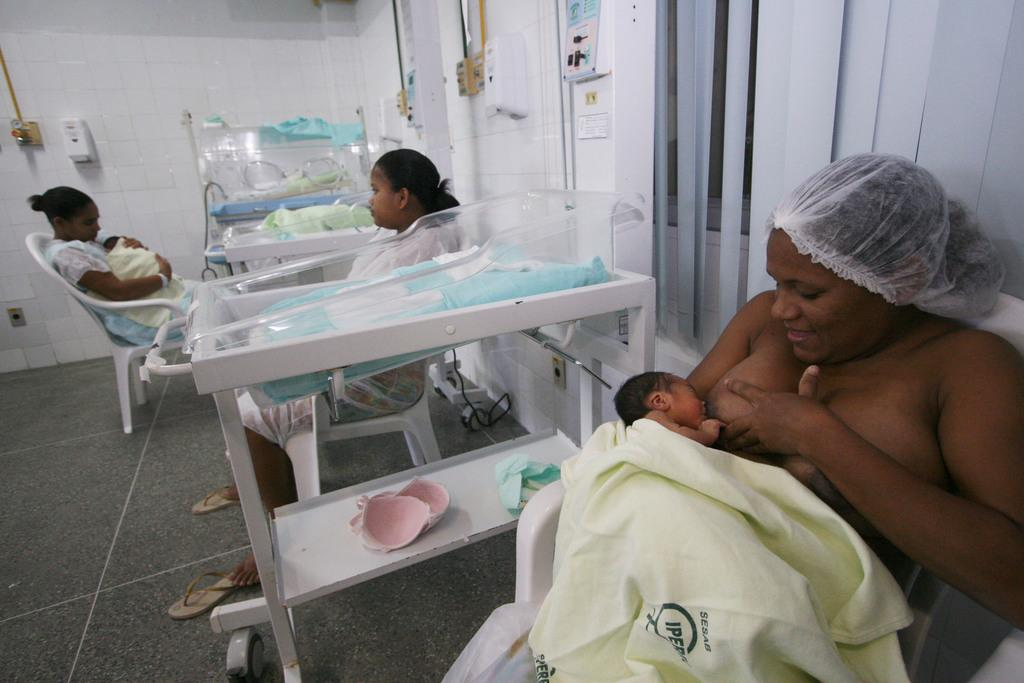How many people are in the image? There are people in the image, specifically two women holding babies. What are the women doing with the babies? The two women are holding babies in the image. What type of furniture is present in the image? There is a chair in the image. What is the background of the image like? The background of the image includes a wall, a window with blinds, and incubator beds. What can be seen on the floor in the image? The floor is visible in the image. How does the sun affect the babies' digestion in the image? The image does not show the sun or any information about the babies' digestion, so it is not possible to answer that question. 